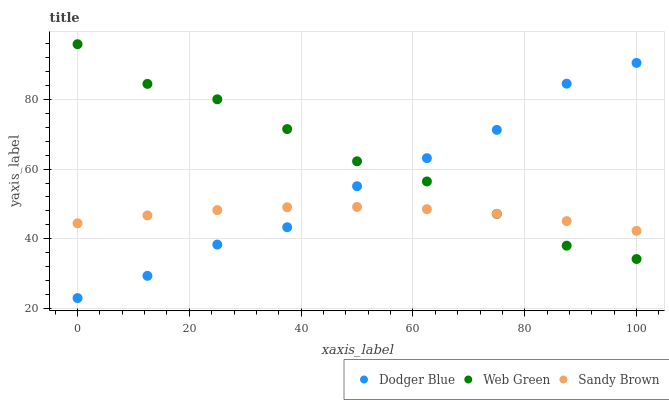Does Sandy Brown have the minimum area under the curve?
Answer yes or no. Yes. Does Web Green have the maximum area under the curve?
Answer yes or no. Yes. Does Dodger Blue have the minimum area under the curve?
Answer yes or no. No. Does Dodger Blue have the maximum area under the curve?
Answer yes or no. No. Is Sandy Brown the smoothest?
Answer yes or no. Yes. Is Dodger Blue the roughest?
Answer yes or no. Yes. Is Web Green the smoothest?
Answer yes or no. No. Is Web Green the roughest?
Answer yes or no. No. Does Dodger Blue have the lowest value?
Answer yes or no. Yes. Does Web Green have the lowest value?
Answer yes or no. No. Does Web Green have the highest value?
Answer yes or no. Yes. Does Dodger Blue have the highest value?
Answer yes or no. No. Does Web Green intersect Dodger Blue?
Answer yes or no. Yes. Is Web Green less than Dodger Blue?
Answer yes or no. No. Is Web Green greater than Dodger Blue?
Answer yes or no. No. 